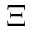Convert formula to latex. <formula><loc_0><loc_0><loc_500><loc_500>\Xi</formula> 